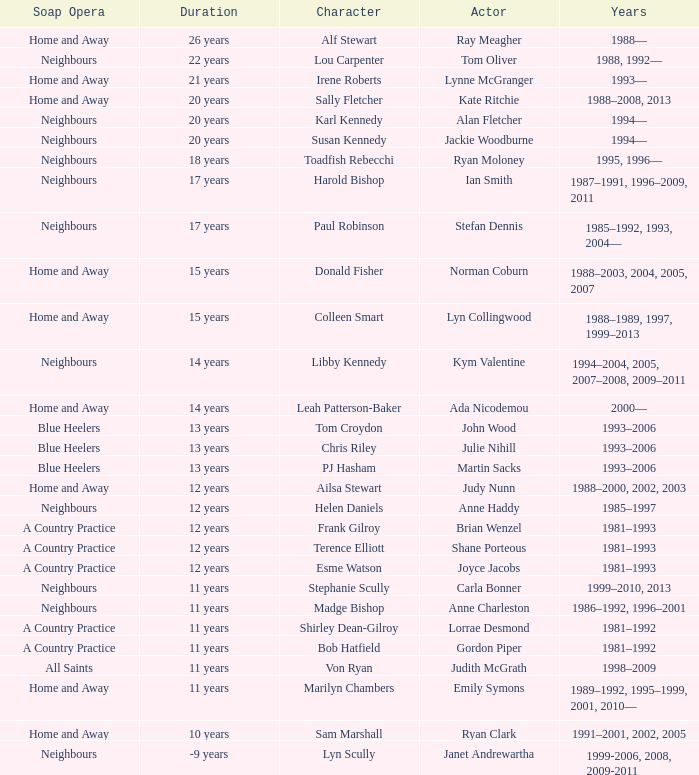Which years did Martin Sacks work on a soap opera? 1993–2006. 